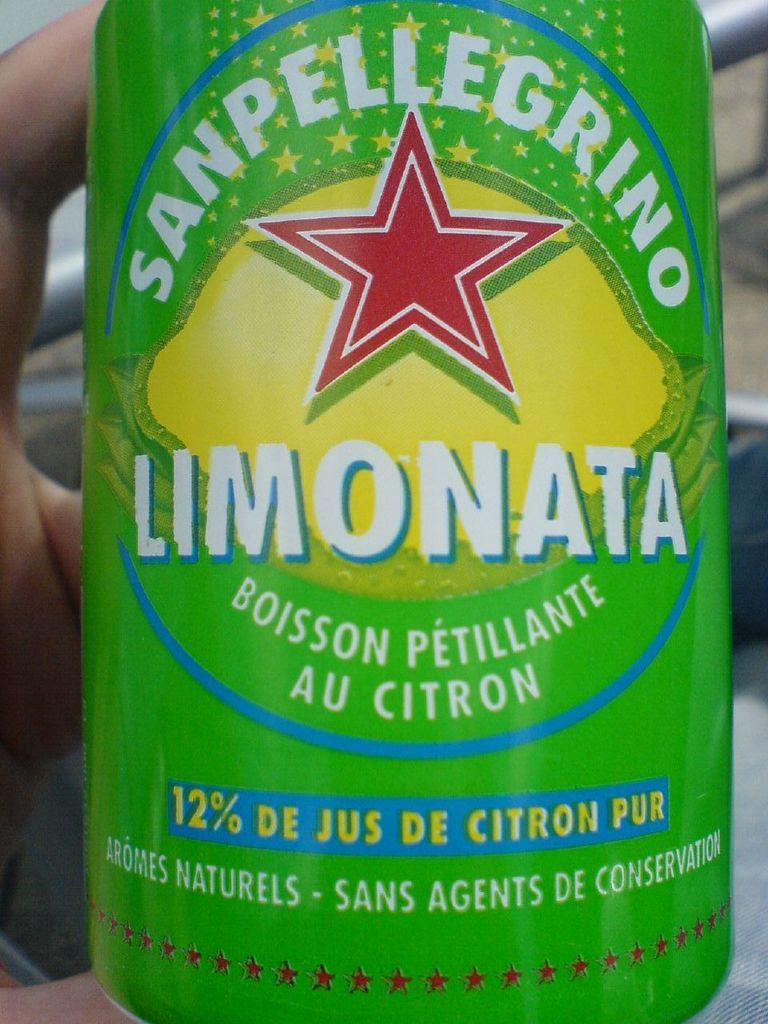What object is present in the picture? There is a tin in the picture. What color is the tin? The tin is green in color. Are there any words or symbols on the tin? Yes, there is text on the tin. What else can be seen in the image? There is a human hand on the left side of the picture. How many jars of jam are visible on the shelf in the image? There is no shelf or jar of jam present in the image. What type of parcel is being held by the hand in the image? There is no parcel visible in the image; only a human hand is present. 